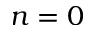<formula> <loc_0><loc_0><loc_500><loc_500>n = 0</formula> 